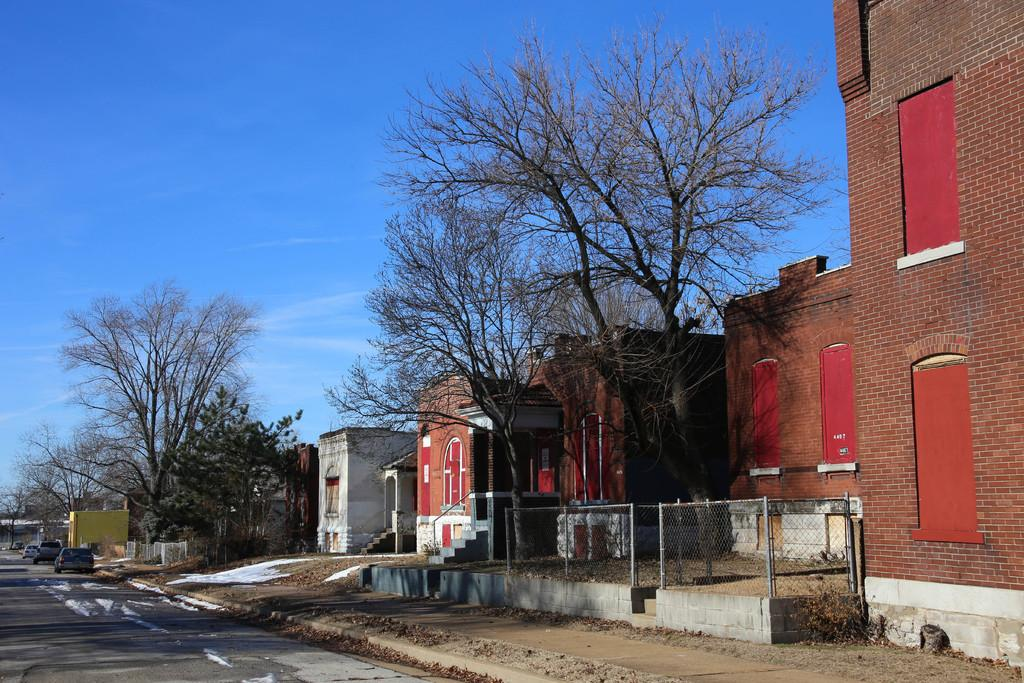What type of structures can be seen in the image? There are buildings in the image. What natural elements are present in the image? There are trees in the image. What type of barrier is visible in the image? There is a fence in the image. What type of transportation can be seen in the image? There are vehicles on the road in the image. What part of the natural environment is visible in the background of the image? The sky is visible in the background of the image. How many sheep are grazing in the image? There are no sheep present in the image. What type of tooth is visible in the image? There are no teeth visible in the image. 